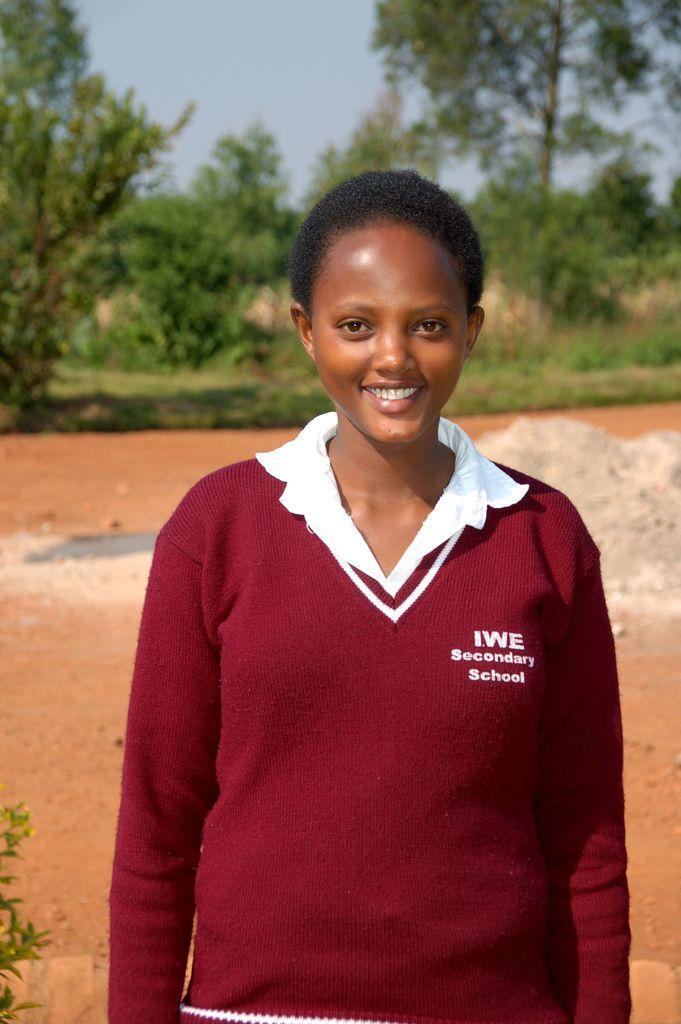Could you give a brief overview of what you see in this image? In this image, there is a person standing and smiling, in the background there are some green color trees, at the top there is a sky. 